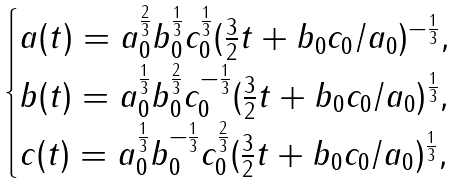Convert formula to latex. <formula><loc_0><loc_0><loc_500><loc_500>\begin{cases} a ( t ) = a _ { 0 } ^ { \frac { 2 } { 3 } } b _ { 0 } ^ { \frac { 1 } { 3 } } c _ { 0 } ^ { \frac { 1 } { 3 } } ( \frac { 3 } { 2 } t + b _ { 0 } c _ { 0 } / a _ { 0 } ) ^ { - \frac { 1 } { 3 } } , \\ b ( t ) = a _ { 0 } ^ { \frac { 1 } { 3 } } b _ { 0 } ^ { \frac { 2 } { 3 } } c _ { 0 } ^ { - \frac { 1 } { 3 } } ( \frac { 3 } { 2 } t + b _ { 0 } c _ { 0 } / a _ { 0 } ) ^ { \frac { 1 } { 3 } } , \\ c ( t ) = a _ { 0 } ^ { \frac { 1 } { 3 } } b _ { 0 } ^ { - \frac { 1 } { 3 } } c _ { 0 } ^ { \frac { 2 } { 3 } } ( \frac { 3 } { 2 } t + b _ { 0 } c _ { 0 } / a _ { 0 } ) ^ { \frac { 1 } { 3 } } , \end{cases}</formula> 